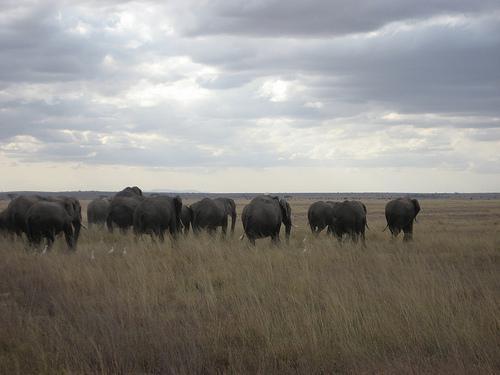How many elephants are in the picture?
Give a very brief answer. 10. 